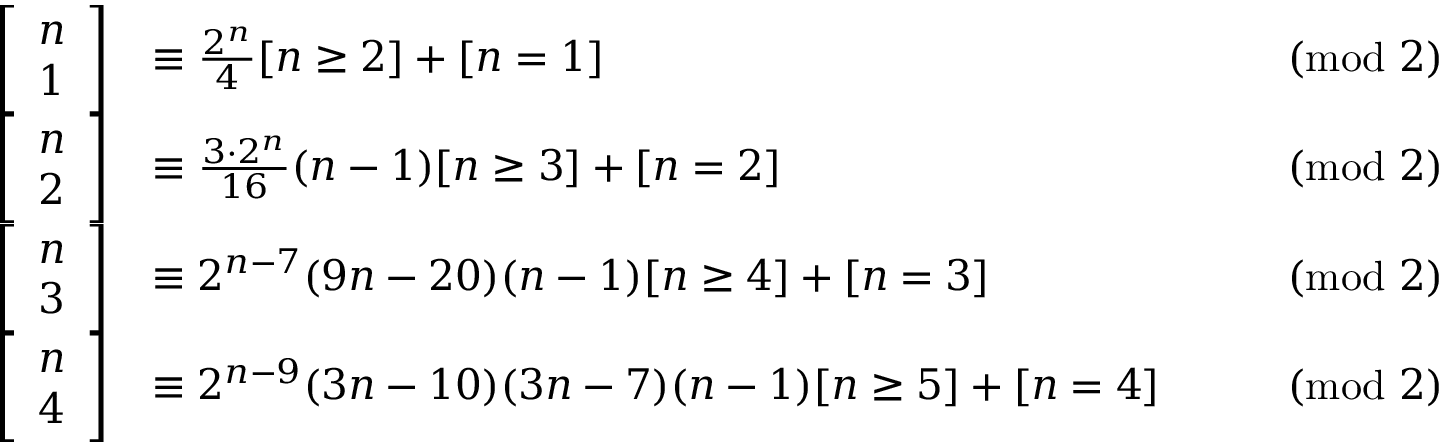Convert formula to latex. <formula><loc_0><loc_0><loc_500><loc_500>{ \begin{array} { r l r l } { \left [ { \begin{array} { l } { n } \\ { 1 } \end{array} } \right ] } & { \equiv \frac { 2 ^ { n } } { 4 } [ n \geq 2 ] + [ n = 1 ] } & & { { \pmod { 2 } } } \\ { \left [ { \begin{array} { l } { n } \\ { 2 } \end{array} } \right ] } & { \equiv \frac { 3 \cdot 2 ^ { n } } { 1 6 } ( n - 1 ) [ n \geq 3 ] + [ n = 2 ] } & & { { \pmod { 2 } } } \\ { \left [ { \begin{array} { l } { n } \\ { 3 } \end{array} } \right ] } & { \equiv 2 ^ { n - 7 } ( 9 n - 2 0 ) ( n - 1 ) [ n \geq 4 ] + [ n = 3 ] } & & { { \pmod { 2 } } } \\ { \left [ { \begin{array} { l } { n } \\ { 4 } \end{array} } \right ] } & { \equiv 2 ^ { n - 9 } ( 3 n - 1 0 ) ( 3 n - 7 ) ( n - 1 ) [ n \geq 5 ] + [ n = 4 ] } & & { { \pmod { 2 } } } \end{array} }</formula> 